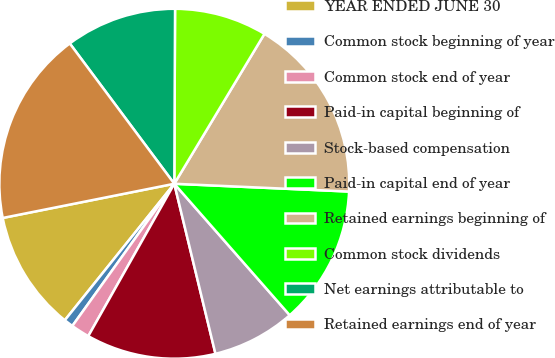Convert chart. <chart><loc_0><loc_0><loc_500><loc_500><pie_chart><fcel>YEAR ENDED JUNE 30<fcel>Common stock beginning of year<fcel>Common stock end of year<fcel>Paid-in capital beginning of<fcel>Stock-based compensation<fcel>Paid-in capital end of year<fcel>Retained earnings beginning of<fcel>Common stock dividends<fcel>Net earnings attributable to<fcel>Retained earnings end of year<nl><fcel>11.11%<fcel>0.86%<fcel>1.72%<fcel>11.96%<fcel>7.69%<fcel>12.82%<fcel>17.09%<fcel>8.55%<fcel>10.26%<fcel>17.94%<nl></chart> 